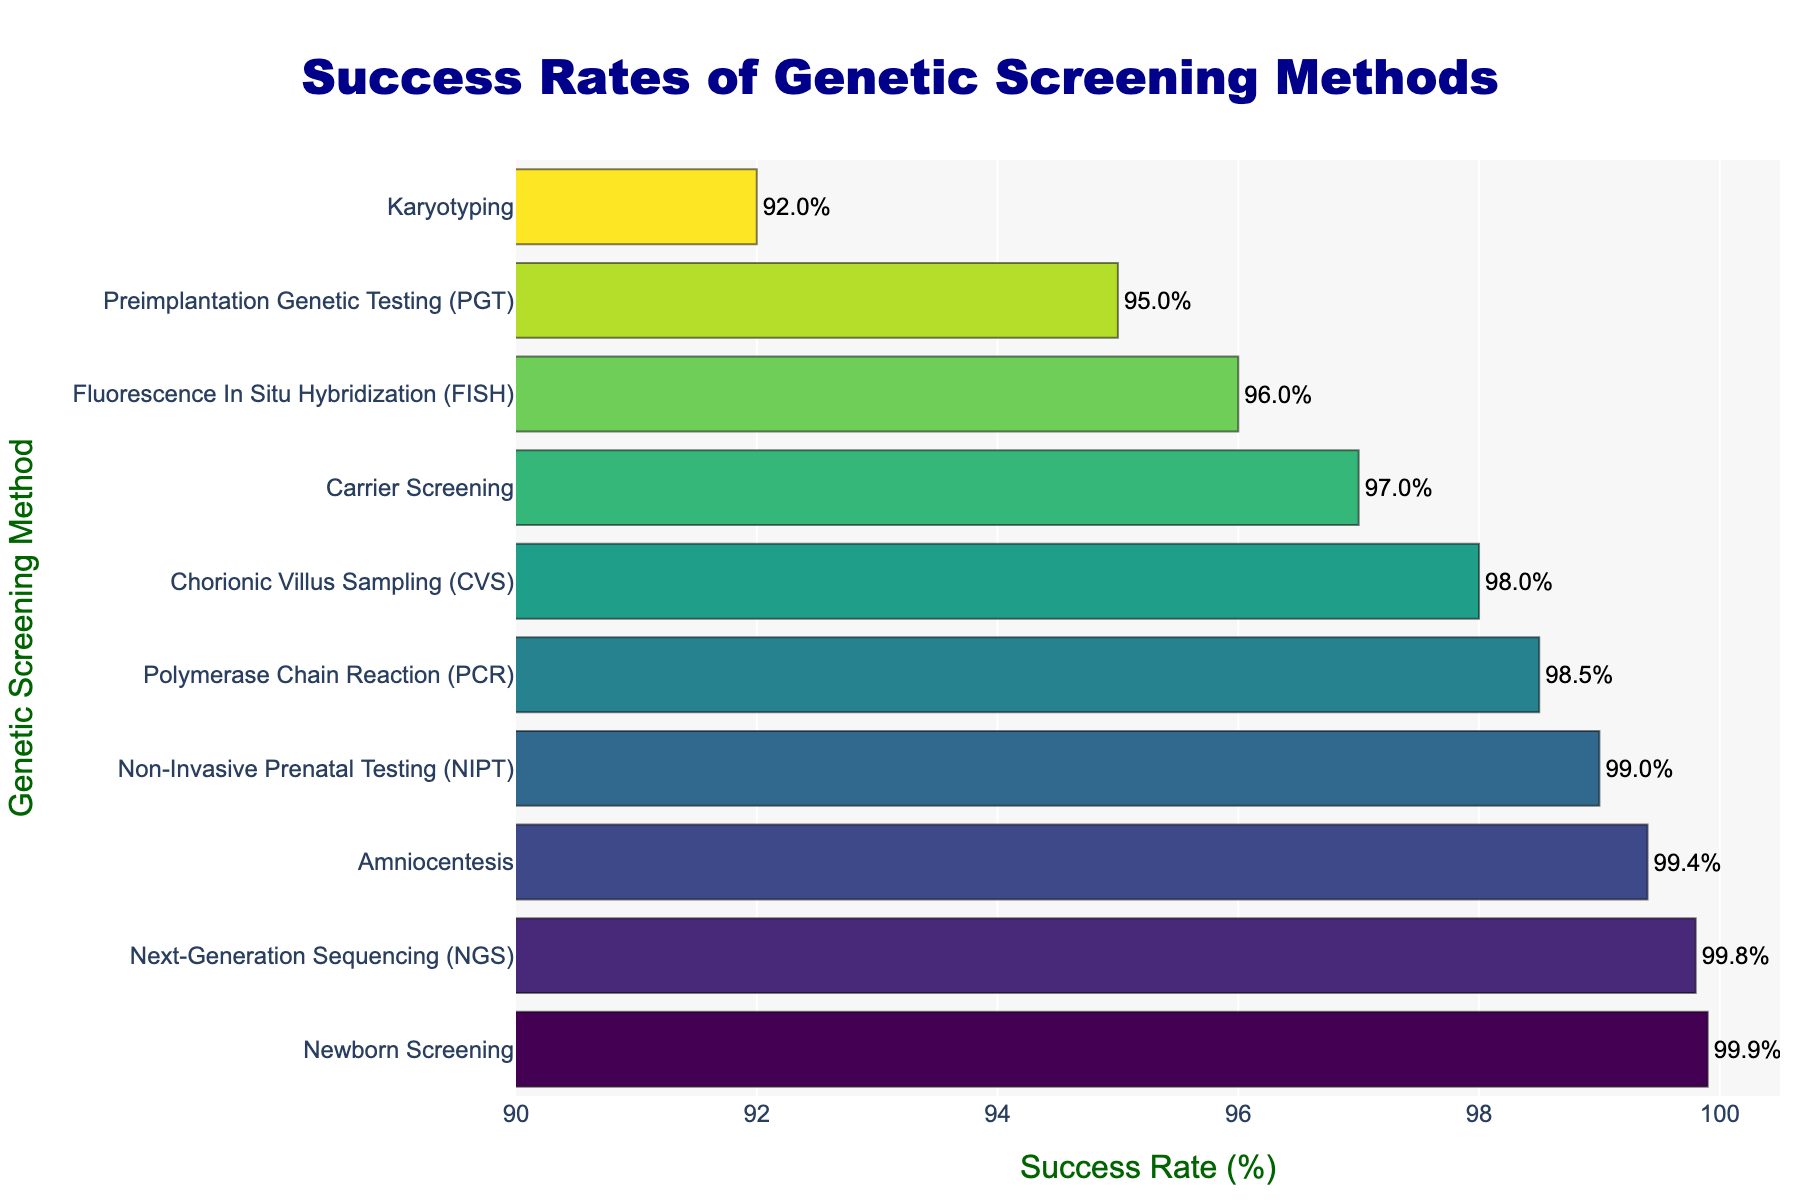Which genetic screening method has the highest success rate? The bar with the highest length/rightmost end on the plot represents the method with the highest success rate.
Answer: Newborn Screening Which screening methods have a success rate greater than 99%? Identify all bars extending beyond the 99% mark on the horizontal axis.
Answer: Newborn Screening, Next-Generation Sequencing (NGS), Amniocentesis, Non-Invasive Prenatal Testing (NIPT) What is the difference in success rates between Karyotyping and PCR? Locate the bars for Karyotyping and PCR, note their success rates, and subtract the smaller from the larger. Karyotyping has 92% and PCR has 98.5%. The difference is 98.5% - 92%.
Answer: 6.5% Which method is more successful, Carrier Screening or Preimplantation Genetic Testing (PGT)? Compare the lengths of the bars for Carrier Screening and PGT. Carrier Screening has 97%, whereas PGT has 95%.
Answer: Carrier Screening What is the average success rate of the top 3 methods? Identify the success rates of the top 3 methods, sum them up, and divide by 3. The top 3 are Newborn Screening (99.9%), Next-Generation Sequencing (NGS) (99.8%), and Amniocentesis (99.4%). The sum is 99.9 + 99.8 + 99.4 = 299.1, and the average is 299.1 / 3.
Answer: 99.7% Which method has the least success rate? Locate the bar that is the shortest or farthest to the left on the plot.
Answer: Karyotyping How much higher is the success rate of Amniocentesis compared to Chorionic Villus Sampling (CVS)? Determine the success rates of both methods and calculate the difference. Amniocentesis has 99.4% and CVS has 98%. The difference is 99.4% - 98%.
Answer: 1.4% Rank the methods from highest to lowest success rates. Order the methods according to the lengths of their bars from the longest (rightmost) to the shortest (leftmost).
Answer: Newborn Screening, Next-Generation Sequencing (NGS), Amniocentesis, Non-Invasive Prenatal Testing (NIPT), Polymerase Chain Reaction (PCR), Chorionic Villus Sampling (CVS), Carrier Screening, Fluorescence In Situ Hybridization (FISH), Preimplantation Genetic Testing (PGT), Karyotyping 